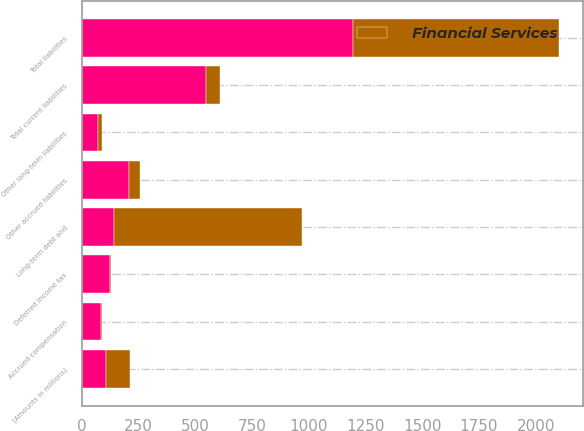Convert chart. <chart><loc_0><loc_0><loc_500><loc_500><stacked_bar_chart><ecel><fcel>(Amounts in millions)<fcel>Accrued compensation<fcel>Other accrued liabilities<fcel>Total current liabilities<fcel>Long-term debt and<fcel>Deferred income tax<fcel>Other long-term liabilities<fcel>Total liabilities<nl><fcel>nan<fcel>105.3<fcel>84.9<fcel>207.8<fcel>545.3<fcel>143.2<fcel>125.7<fcel>69.9<fcel>1193.2<nl><fcel>Financial Services<fcel>105.3<fcel>3.4<fcel>46.9<fcel>64.8<fcel>827.2<fcel>1.4<fcel>17.6<fcel>911<nl></chart> 